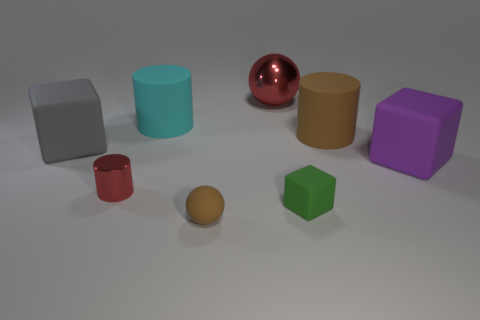What number of other objects are the same size as the gray cube?
Give a very brief answer. 4. There is a big thing that is to the left of the red object that is to the left of the red object behind the gray cube; what is its material?
Make the answer very short. Rubber. There is a red cylinder; is its size the same as the matte cylinder that is right of the small block?
Give a very brief answer. No. There is a rubber cube that is behind the small block and on the right side of the large red thing; what size is it?
Ensure brevity in your answer.  Large. Is there a large matte cylinder of the same color as the small ball?
Provide a short and direct response. Yes. What color is the big block left of the red thing to the right of the rubber ball?
Your answer should be very brief. Gray. Is the number of tiny red cylinders that are in front of the small brown sphere less than the number of cyan objects in front of the tiny red cylinder?
Your answer should be very brief. No. Does the cyan rubber object have the same size as the gray object?
Provide a succinct answer. Yes. There is a rubber object that is both in front of the large gray matte cube and on the right side of the green cube; what is its shape?
Provide a succinct answer. Cube. How many red things have the same material as the red cylinder?
Your answer should be very brief. 1. 